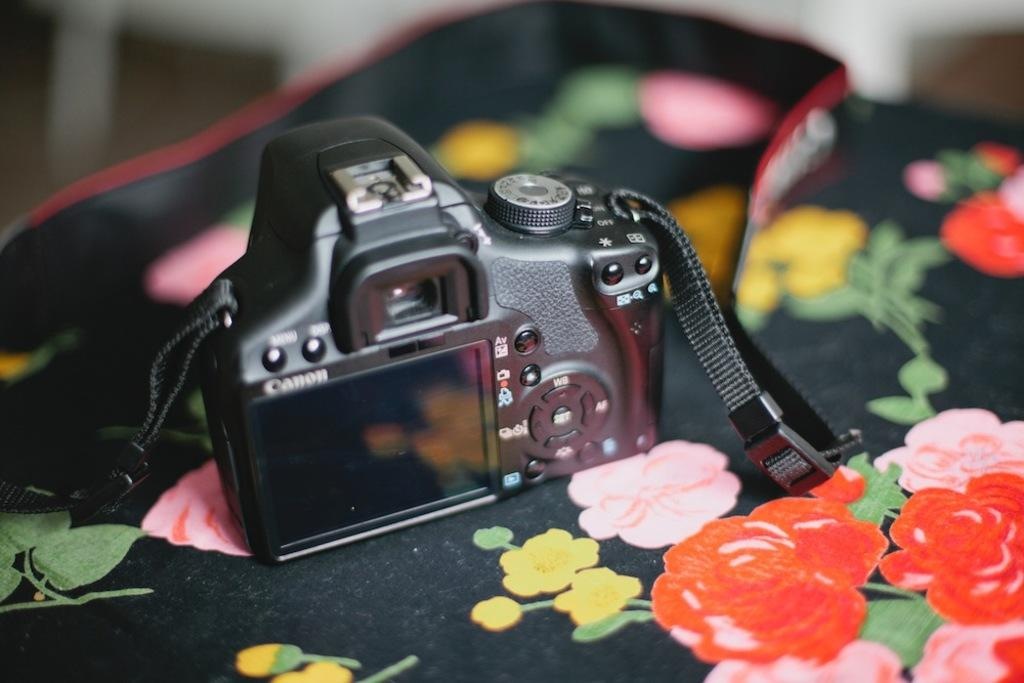What is the main object in the image? There is a camera in the image. How is the camera positioned in the image? The camera is placed on a cloth. What type of pattern is visible on the cloth? The cloth has a floral print. Where is the fowl's nest located in the image? There is no fowl or nest present in the image. What type of kettle is visible in the image? There is no kettle present in the image. 